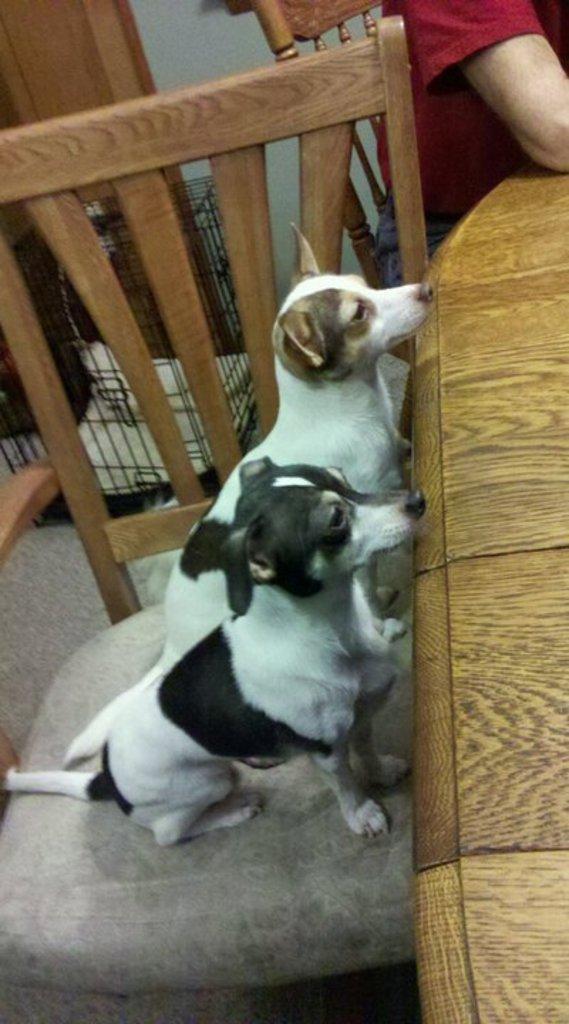In one or two sentences, can you explain what this image depicts? In the center we can see dogs on the chair around the table. On the right top we can see on person sitting on the chair. and back we can see wall and cage. 